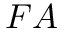<formula> <loc_0><loc_0><loc_500><loc_500>F A</formula> 